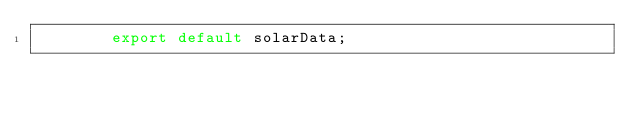<code> <loc_0><loc_0><loc_500><loc_500><_JavaScript_>        export default solarData;
      </code> 